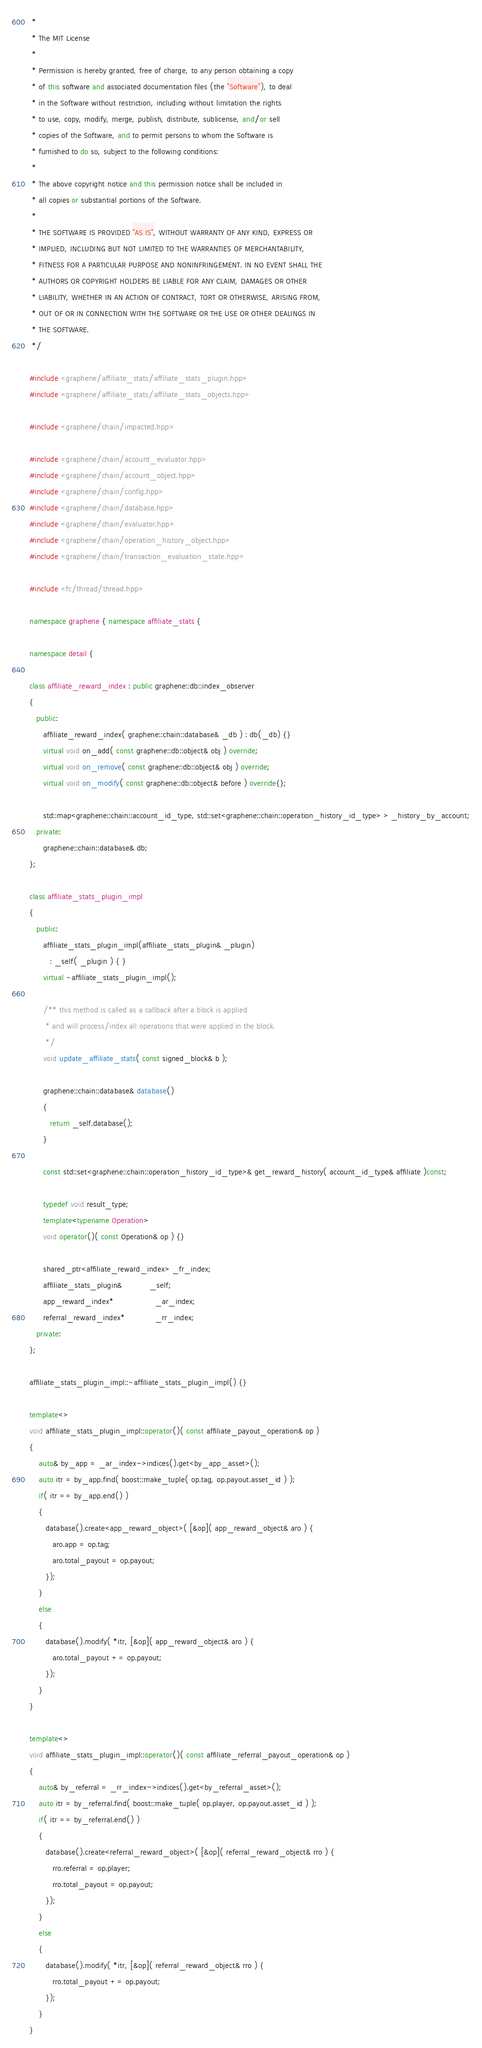Convert code to text. <code><loc_0><loc_0><loc_500><loc_500><_C++_> *
 * The MIT License
 *
 * Permission is hereby granted, free of charge, to any person obtaining a copy
 * of this software and associated documentation files (the "Software"), to deal
 * in the Software without restriction, including without limitation the rights
 * to use, copy, modify, merge, publish, distribute, sublicense, and/or sell
 * copies of the Software, and to permit persons to whom the Software is
 * furnished to do so, subject to the following conditions:
 *
 * The above copyright notice and this permission notice shall be included in
 * all copies or substantial portions of the Software.
 *
 * THE SOFTWARE IS PROVIDED "AS IS", WITHOUT WARRANTY OF ANY KIND, EXPRESS OR
 * IMPLIED, INCLUDING BUT NOT LIMITED TO THE WARRANTIES OF MERCHANTABILITY,
 * FITNESS FOR A PARTICULAR PURPOSE AND NONINFRINGEMENT. IN NO EVENT SHALL THE
 * AUTHORS OR COPYRIGHT HOLDERS BE LIABLE FOR ANY CLAIM, DAMAGES OR OTHER
 * LIABILITY, WHETHER IN AN ACTION OF CONTRACT, TORT OR OTHERWISE, ARISING FROM,
 * OUT OF OR IN CONNECTION WITH THE SOFTWARE OR THE USE OR OTHER DEALINGS IN
 * THE SOFTWARE.
 */

#include <graphene/affiliate_stats/affiliate_stats_plugin.hpp>
#include <graphene/affiliate_stats/affiliate_stats_objects.hpp>

#include <graphene/chain/impacted.hpp>

#include <graphene/chain/account_evaluator.hpp>
#include <graphene/chain/account_object.hpp>
#include <graphene/chain/config.hpp>
#include <graphene/chain/database.hpp>
#include <graphene/chain/evaluator.hpp>
#include <graphene/chain/operation_history_object.hpp>
#include <graphene/chain/transaction_evaluation_state.hpp>

#include <fc/thread/thread.hpp>

namespace graphene { namespace affiliate_stats {

namespace detail {

class affiliate_reward_index : public graphene::db::index_observer
{
   public:
      affiliate_reward_index( graphene::chain::database& _db ) : db(_db) {}
      virtual void on_add( const graphene::db::object& obj ) override;
      virtual void on_remove( const graphene::db::object& obj ) override;
      virtual void on_modify( const graphene::db::object& before ) override{};

      std::map<graphene::chain::account_id_type, std::set<graphene::chain::operation_history_id_type> > _history_by_account;
   private:
      graphene::chain::database& db;
};

class affiliate_stats_plugin_impl
{
   public:
      affiliate_stats_plugin_impl(affiliate_stats_plugin& _plugin)
         : _self( _plugin ) { }
      virtual ~affiliate_stats_plugin_impl();

      /** this method is called as a callback after a block is applied
       * and will process/index all operations that were applied in the block.
       */
      void update_affiliate_stats( const signed_block& b );

      graphene::chain::database& database()
      {
         return _self.database();
      }

      const std::set<graphene::chain::operation_history_id_type>& get_reward_history( account_id_type& affiliate )const;

      typedef void result_type;
      template<typename Operation>
      void operator()( const Operation& op ) {}

      shared_ptr<affiliate_reward_index> _fr_index;
      affiliate_stats_plugin&            _self;
      app_reward_index*                  _ar_index;
      referral_reward_index*             _rr_index;
   private:
};

affiliate_stats_plugin_impl::~affiliate_stats_plugin_impl() {}

template<>
void affiliate_stats_plugin_impl::operator()( const affiliate_payout_operation& op )
{
    auto& by_app = _ar_index->indices().get<by_app_asset>();
    auto itr = by_app.find( boost::make_tuple( op.tag, op.payout.asset_id ) );
    if( itr == by_app.end() )
    {
       database().create<app_reward_object>( [&op]( app_reward_object& aro ) {
          aro.app = op.tag;
          aro.total_payout = op.payout;
       });
    }
    else
    {
       database().modify( *itr, [&op]( app_reward_object& aro ) {
          aro.total_payout += op.payout;
       });
    }
}

template<>
void affiliate_stats_plugin_impl::operator()( const affiliate_referral_payout_operation& op )
{
    auto& by_referral = _rr_index->indices().get<by_referral_asset>();
    auto itr = by_referral.find( boost::make_tuple( op.player, op.payout.asset_id ) );
    if( itr == by_referral.end() )
    {
       database().create<referral_reward_object>( [&op]( referral_reward_object& rro ) {
          rro.referral = op.player;
          rro.total_payout = op.payout;
       });
    }
    else
    {
       database().modify( *itr, [&op]( referral_reward_object& rro ) {
          rro.total_payout += op.payout;
       });
    }
}
</code> 